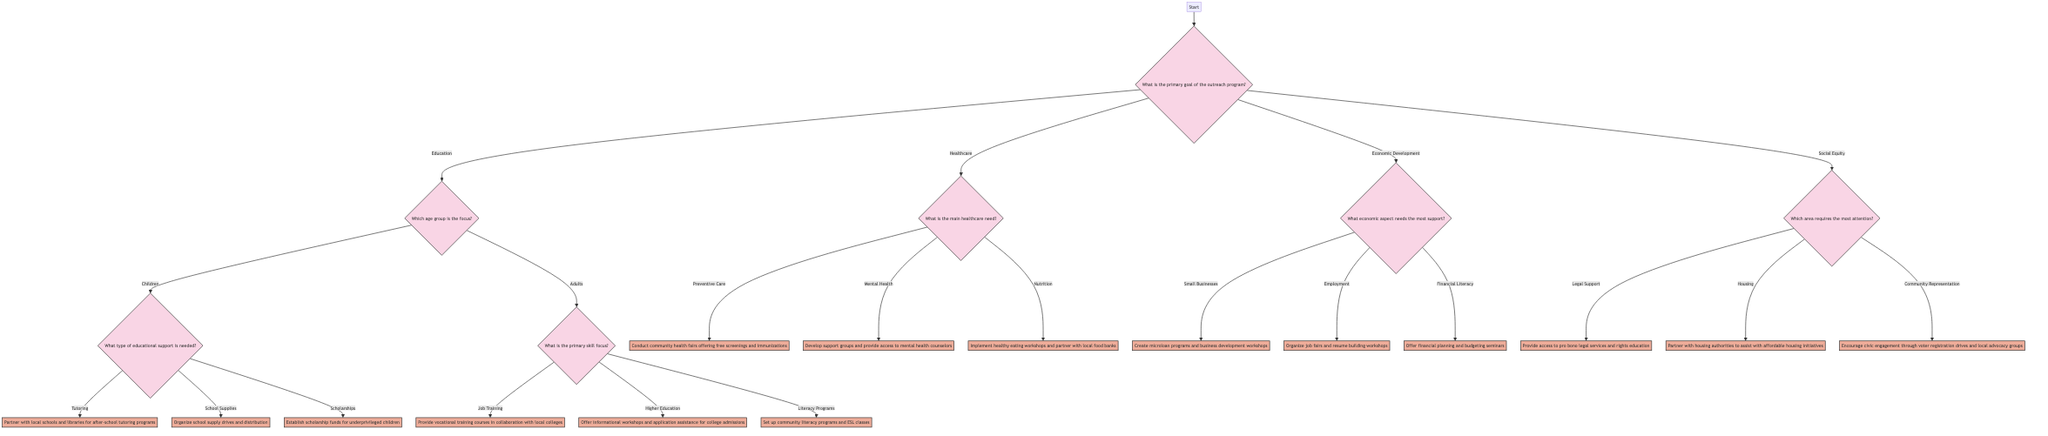What is the primary goal of the outreach program? The root node of the decision tree asks for the primary goal of the outreach program, which has four main options: Education, Healthcare, Economic Development, and Social Equity.
Answer: Education How many options are available under the focus age group for education? After selecting Education, the next question asks about the focus age group, which has two options: Children and Adults. Thus, there are a total of two options under this node.
Answer: 2 What action is suggested for small businesses? Under the Economic Development branch, when selecting Small Businesses, the action listed is to create microloan programs and business development workshops.
Answer: Create microloan programs and business development workshops Which area of social equity requires the most attention? The Social Equity branch asks for which area requires the most attention, with options including Legal Support, Housing, and Community Representation. Hence, any of these would be correct depending on chosen direction, but the question asks strictly about this node and does not indicate a choice.
Answer: Legal Support What type of educational support can be organized for children? The node connected to Children under the Educational focus offers several options for support, including tutoring, school supplies, and scholarships. The action for tutoring explicitly states partnering with schools and libraries for after-school programs.
Answer: Partner with local schools and libraries for after-school tutoring programs What is the action related to mental health? For the healthcare segment, when selecting Mental Health, the action specified is to develop support groups and provide access to mental health counselors. This directly reflects the response expected when navigating this branch of the tree.
Answer: Develop support groups and provide access to mental health counselors If the focus is on higher education, what action should be taken? Under the Adults section of the education branch, the option of Higher Education leads to the action of offering informational workshops and application assistance for college admissions. This indicates how to proceed if that path is chosen.
Answer: Offer informational workshops and application assistance for college admissions Which node follows after selecting Nutrition in healthcare? In the healthcare category, choosing Nutrition leads to the action node that describes implementing healthy eating workshops and partnering with local food banks. This showcases the action outcome based on the selected pathway.
Answer: Implement healthy eating workshops and partner with local food banks 